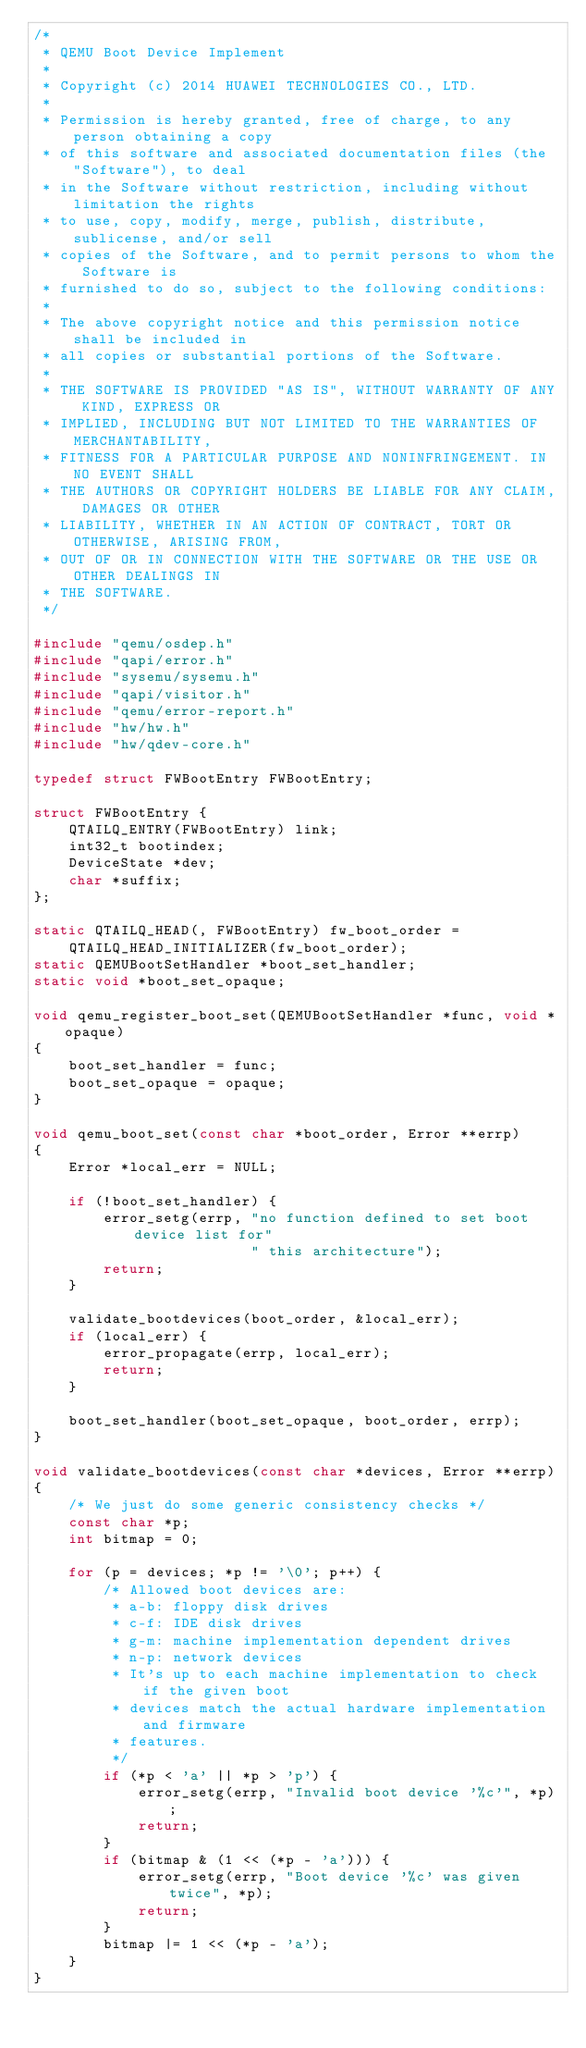Convert code to text. <code><loc_0><loc_0><loc_500><loc_500><_C_>/*
 * QEMU Boot Device Implement
 *
 * Copyright (c) 2014 HUAWEI TECHNOLOGIES CO., LTD.
 *
 * Permission is hereby granted, free of charge, to any person obtaining a copy
 * of this software and associated documentation files (the "Software"), to deal
 * in the Software without restriction, including without limitation the rights
 * to use, copy, modify, merge, publish, distribute, sublicense, and/or sell
 * copies of the Software, and to permit persons to whom the Software is
 * furnished to do so, subject to the following conditions:
 *
 * The above copyright notice and this permission notice shall be included in
 * all copies or substantial portions of the Software.
 *
 * THE SOFTWARE IS PROVIDED "AS IS", WITHOUT WARRANTY OF ANY KIND, EXPRESS OR
 * IMPLIED, INCLUDING BUT NOT LIMITED TO THE WARRANTIES OF MERCHANTABILITY,
 * FITNESS FOR A PARTICULAR PURPOSE AND NONINFRINGEMENT. IN NO EVENT SHALL
 * THE AUTHORS OR COPYRIGHT HOLDERS BE LIABLE FOR ANY CLAIM, DAMAGES OR OTHER
 * LIABILITY, WHETHER IN AN ACTION OF CONTRACT, TORT OR OTHERWISE, ARISING FROM,
 * OUT OF OR IN CONNECTION WITH THE SOFTWARE OR THE USE OR OTHER DEALINGS IN
 * THE SOFTWARE.
 */

#include "qemu/osdep.h"
#include "qapi/error.h"
#include "sysemu/sysemu.h"
#include "qapi/visitor.h"
#include "qemu/error-report.h"
#include "hw/hw.h"
#include "hw/qdev-core.h"

typedef struct FWBootEntry FWBootEntry;

struct FWBootEntry {
    QTAILQ_ENTRY(FWBootEntry) link;
    int32_t bootindex;
    DeviceState *dev;
    char *suffix;
};

static QTAILQ_HEAD(, FWBootEntry) fw_boot_order =
    QTAILQ_HEAD_INITIALIZER(fw_boot_order);
static QEMUBootSetHandler *boot_set_handler;
static void *boot_set_opaque;

void qemu_register_boot_set(QEMUBootSetHandler *func, void *opaque)
{
    boot_set_handler = func;
    boot_set_opaque = opaque;
}

void qemu_boot_set(const char *boot_order, Error **errp)
{
    Error *local_err = NULL;

    if (!boot_set_handler) {
        error_setg(errp, "no function defined to set boot device list for"
                         " this architecture");
        return;
    }

    validate_bootdevices(boot_order, &local_err);
    if (local_err) {
        error_propagate(errp, local_err);
        return;
    }

    boot_set_handler(boot_set_opaque, boot_order, errp);
}

void validate_bootdevices(const char *devices, Error **errp)
{
    /* We just do some generic consistency checks */
    const char *p;
    int bitmap = 0;

    for (p = devices; *p != '\0'; p++) {
        /* Allowed boot devices are:
         * a-b: floppy disk drives
         * c-f: IDE disk drives
         * g-m: machine implementation dependent drives
         * n-p: network devices
         * It's up to each machine implementation to check if the given boot
         * devices match the actual hardware implementation and firmware
         * features.
         */
        if (*p < 'a' || *p > 'p') {
            error_setg(errp, "Invalid boot device '%c'", *p);
            return;
        }
        if (bitmap & (1 << (*p - 'a'))) {
            error_setg(errp, "Boot device '%c' was given twice", *p);
            return;
        }
        bitmap |= 1 << (*p - 'a');
    }
}
</code> 